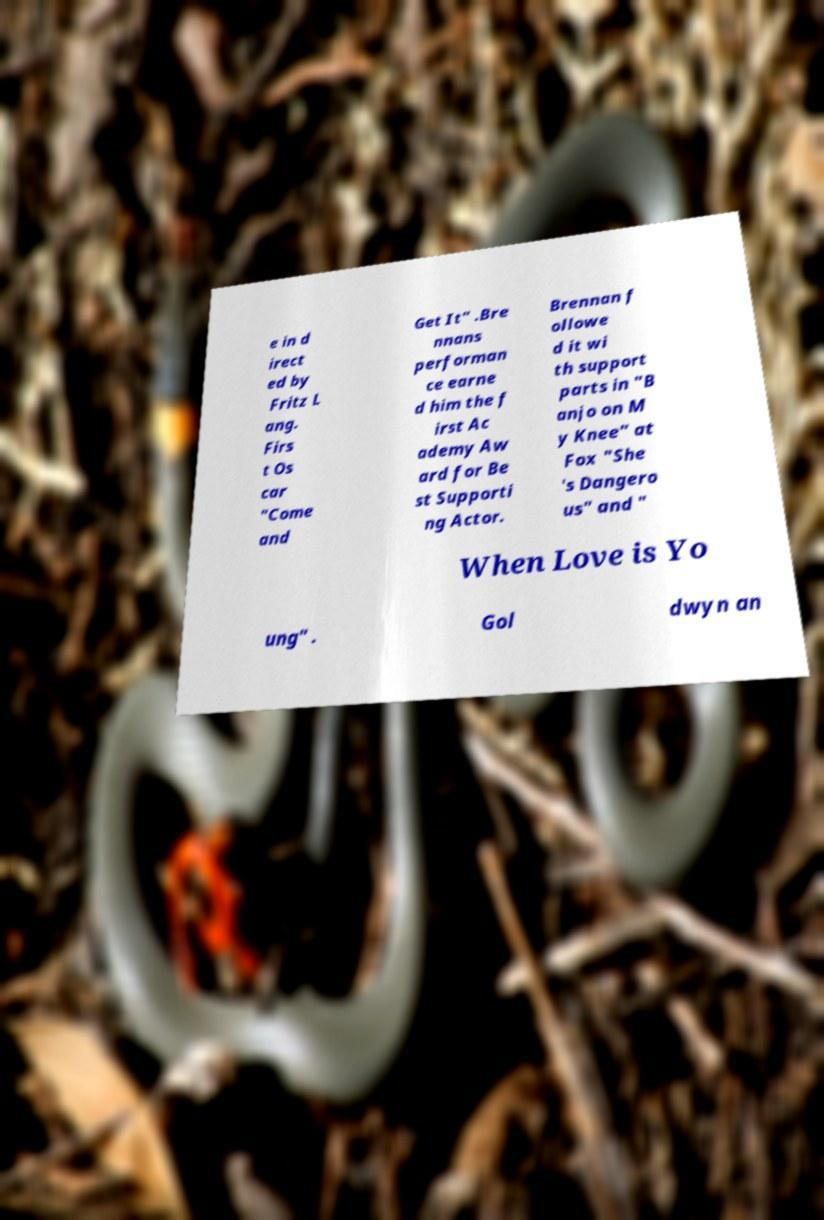Can you accurately transcribe the text from the provided image for me? e in d irect ed by Fritz L ang. Firs t Os car "Come and Get It" .Bre nnans performan ce earne d him the f irst Ac ademy Aw ard for Be st Supporti ng Actor. Brennan f ollowe d it wi th support parts in "B anjo on M y Knee" at Fox "She 's Dangero us" and " When Love is Yo ung" . Gol dwyn an 